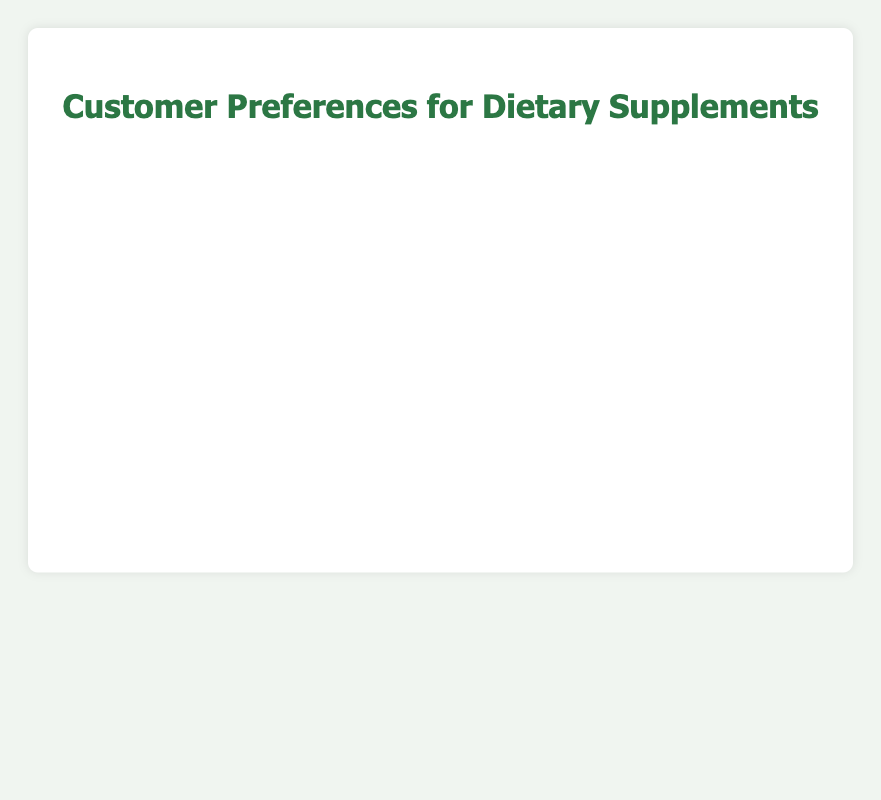Which dietary supplement do the highest percentage of customers prefer? The chart shows that 'Multivitamins' has the highest bar, indicating the highest percentage of customer preference.
Answer: Multivitamins Which dietary supplement has the lowest customer preference? The chart reveals 'Protein Supplements' with the shortest bar, indicating the lowest percentage of customer preference.
Answer: Protein Supplements What is the percentage difference between customers preferring Multivitamins and those preferring Protein Supplements? Customers preferring Multivitamins is 35%, and Protein Supplements is 5%. The difference is calculated as 35% - 5% = 30%.
Answer: 30% Is the percentage of customers preferring Vitamin D greater than those preferring Probiotics? The chart shows the bar for Vitamin D reaches 25%, while the bar for Probiotics reaches 18%, indicating Vitamin D has a greater preference.
Answer: Yes What is the combined percentage of customers preferring Omega-3 Fatty Acids and Probiotics? The percentage for Omega-3 Fatty Acids is 20% and for Probiotics is 18%. The combined percentage is 20% + 18% = 38%.
Answer: 38% Which supplement has the longest bar in the chart? The chart displays the longest bar for 'Multivitamins', indicating it has the highest customer preference.
Answer: Multivitamins How does the percentage of customers preferring Vitamin C compare to those preferring Calcium? Vitamin C has a percentage of 15%, and Calcium has a percentage of 12%. Hence, more customers prefer Vitamin C than Calcium.
Answer: More What is the average percentage of customers for the top three preferred supplements (Multivitamins, Vitamin D, Omega-3 Fatty Acids)? The percentages for the top three supplements are 35% for Multivitamins, 25% for Vitamin D, and 20% for Omega-3 Fatty Acids. The average is calculated as (35% + 25% + 20%) / 3 = 80% / 3 ≈ 26.67%.
Answer: 26.67% Which supplement has a percentage of customer preference in the range of 10% to 20%? The chart shows 'Probiotics' with 18%, 'Calcium' with 12%, and 'Herbal Supplements' with 10% all fall within the 10-20% range.
Answer: Probiotics, Calcium, Herbal Supplements Is the percentage of customers preferring Iron greater or less than those preferring Magnesium? The chart indicates that Iron has a percentage of 8%, while Magnesium has 7%, showing Iron has a slightly greater preference.
Answer: Greater 